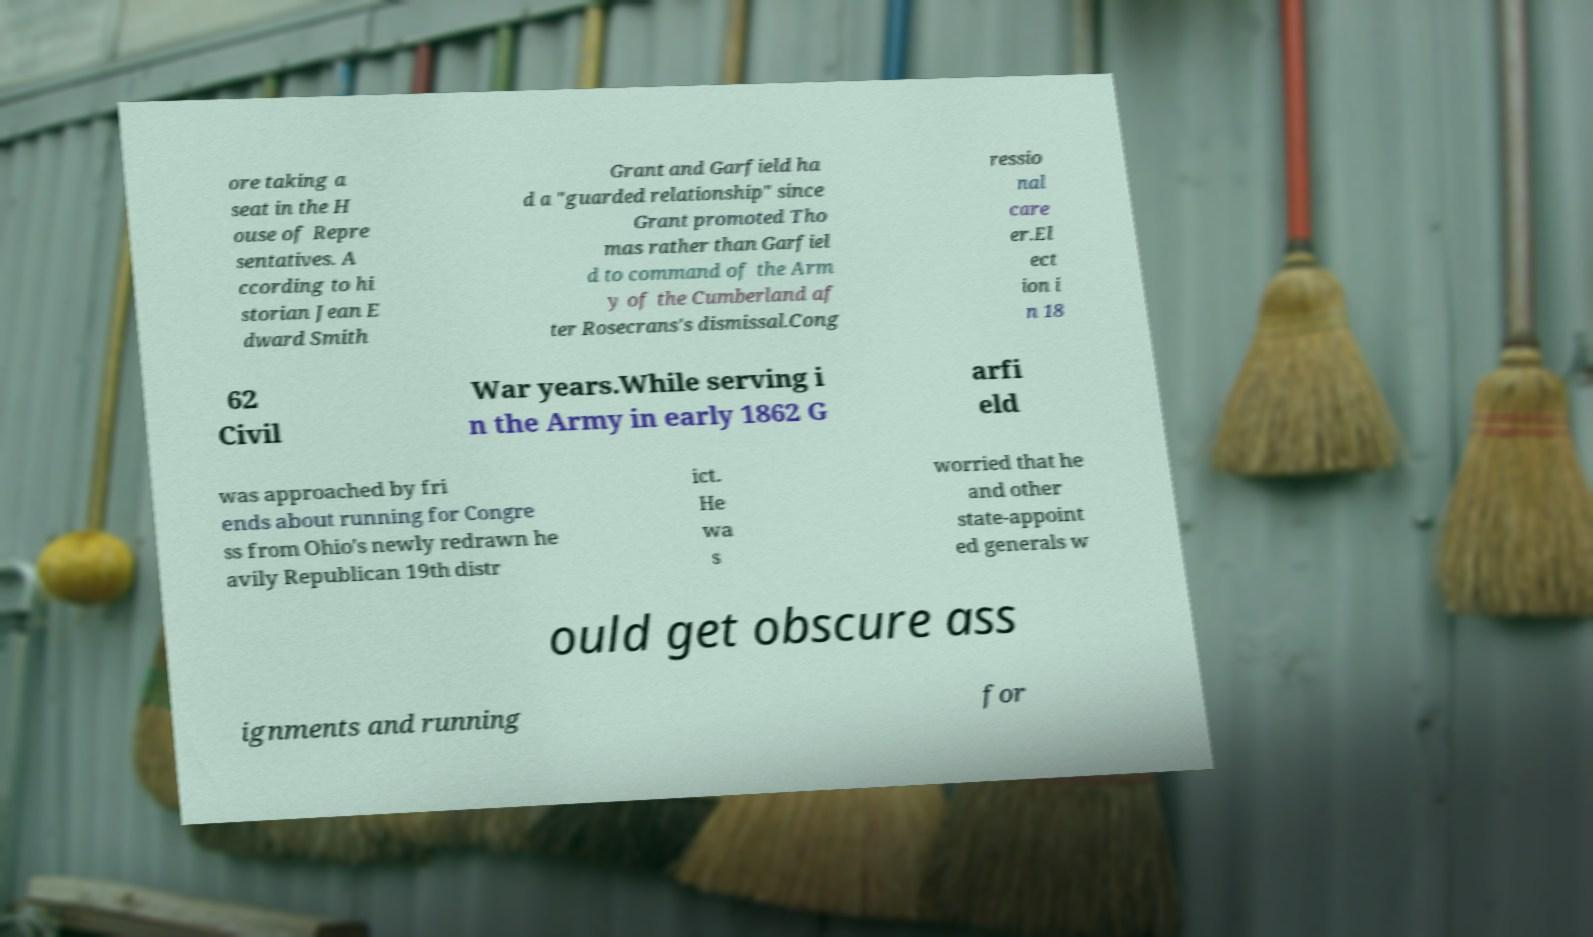Can you read and provide the text displayed in the image?This photo seems to have some interesting text. Can you extract and type it out for me? ore taking a seat in the H ouse of Repre sentatives. A ccording to hi storian Jean E dward Smith Grant and Garfield ha d a "guarded relationship" since Grant promoted Tho mas rather than Garfiel d to command of the Arm y of the Cumberland af ter Rosecrans's dismissal.Cong ressio nal care er.El ect ion i n 18 62 Civil War years.While serving i n the Army in early 1862 G arfi eld was approached by fri ends about running for Congre ss from Ohio's newly redrawn he avily Republican 19th distr ict. He wa s worried that he and other state-appoint ed generals w ould get obscure ass ignments and running for 